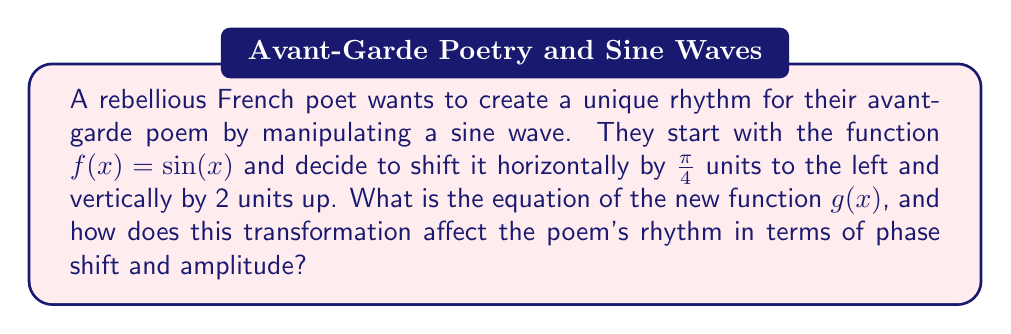Can you answer this question? Let's approach this step-by-step:

1) The original function is $f(x) = \sin(x)$.

2) To shift a function horizontally by $h$ units to the left, we replace $x$ with $(x + h)$. In this case, $h = \frac{\pi}{4}$. So, after the horizontal shift, we have:

   $\sin(x + \frac{\pi}{4})$

3) To shift a function vertically by $k$ units up, we add $k$ to the function. Here, $k = 2$. So, after applying both transformations, we get:

   $g(x) = \sin(x + \frac{\pi}{4}) + 2$

4) Effect on the poem's rhythm:

   a) Phase shift: The horizontal shift of $\frac{\pi}{4}$ units to the left creates a phase shift. This means the poem's rhythm will start $\frac{\pi}{4}$ radians (or 45 degrees) earlier in its cycle. In poetic terms, this could represent starting the rhythmic pattern slightly before the expected beat, creating a sense of anticipation or urgency.

   b) Amplitude: The vertical shift doesn't change the amplitude of the sine wave, which remains 1. However, the entire wave is now oscillating around $y = 2$ instead of $y = 0$. In the context of the poem, this could be interpreted as maintaining the same intensity of rhythmic variation but at a "higher" emotional or tonal level throughout the piece.

The combination of these transformations results in a poem that begins its rhythmic cycle earlier than expected and maintains an elevated emotional tone, perfectly embodying the rebellious and unconventional nature of the French poet.
Answer: $g(x) = \sin(x + \frac{\pi}{4}) + 2$ 